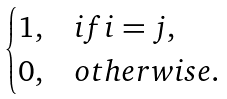<formula> <loc_0><loc_0><loc_500><loc_500>\begin{cases} 1 , & i f i = j , \\ 0 , & o t h e r w i s e . \end{cases}</formula> 